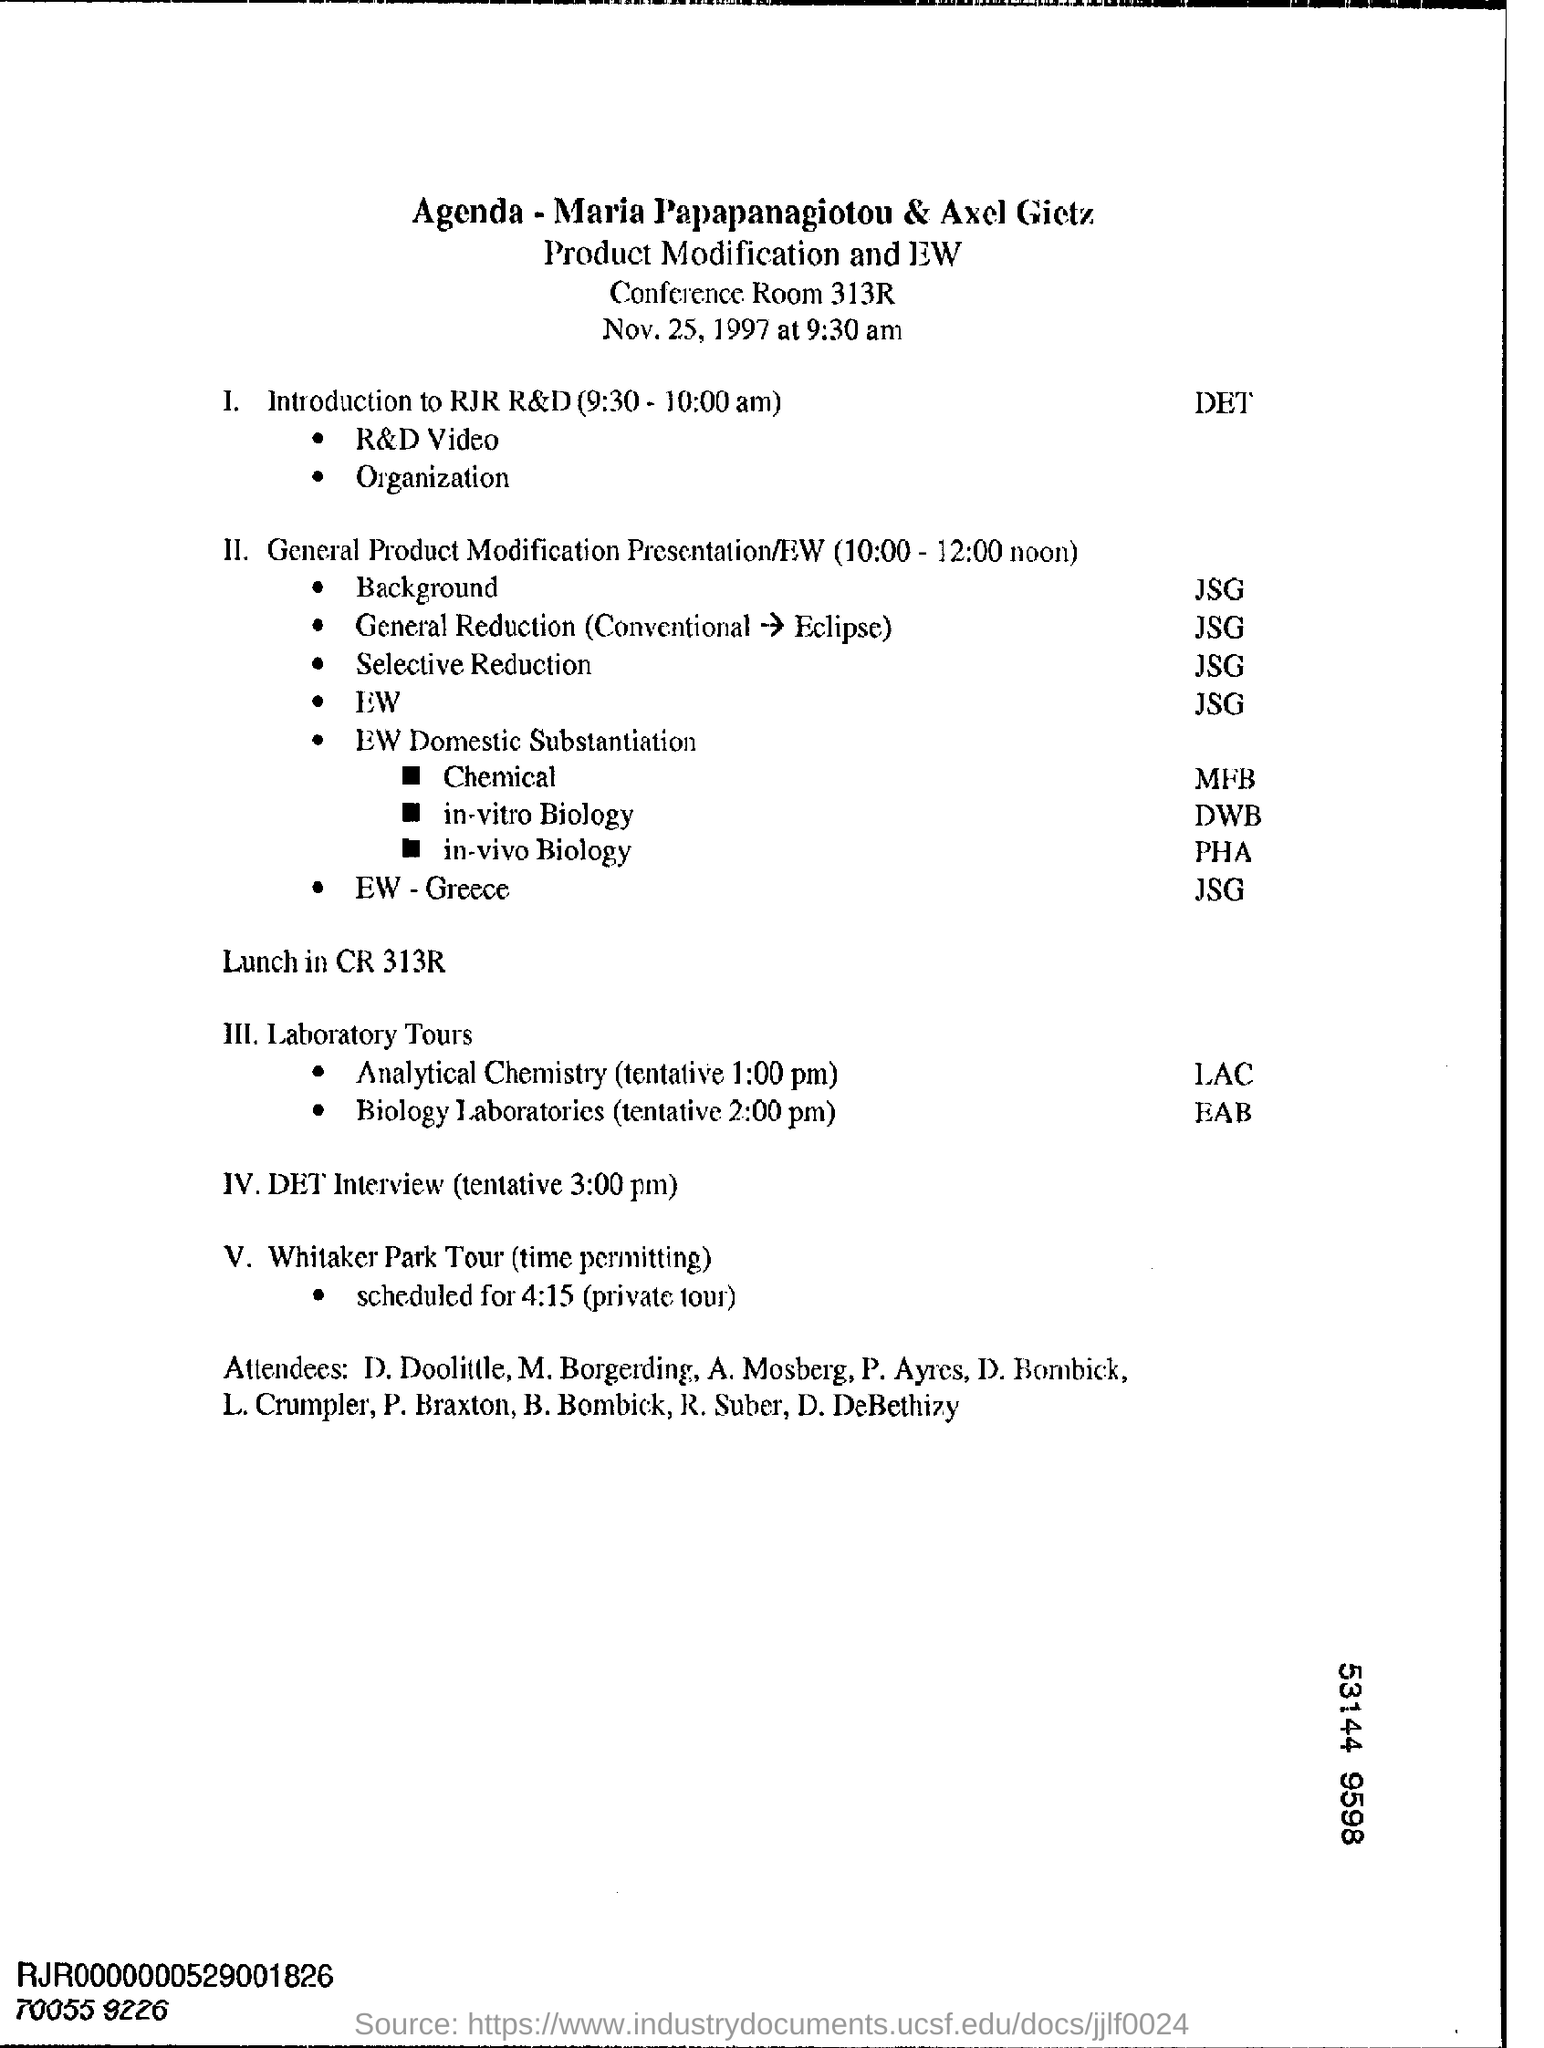List a handful of essential elements in this visual. The venue for lunch is? At 3:00 pm, the DET interview is scheduled for a tentative time. 